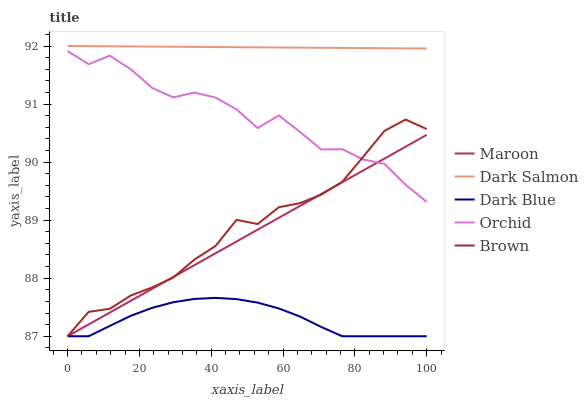Does Dark Blue have the minimum area under the curve?
Answer yes or no. Yes. Does Dark Salmon have the maximum area under the curve?
Answer yes or no. Yes. Does Dark Salmon have the minimum area under the curve?
Answer yes or no. No. Does Dark Blue have the maximum area under the curve?
Answer yes or no. No. Is Dark Salmon the smoothest?
Answer yes or no. Yes. Is Orchid the roughest?
Answer yes or no. Yes. Is Dark Blue the smoothest?
Answer yes or no. No. Is Dark Blue the roughest?
Answer yes or no. No. Does Brown have the lowest value?
Answer yes or no. Yes. Does Dark Salmon have the lowest value?
Answer yes or no. No. Does Dark Salmon have the highest value?
Answer yes or no. Yes. Does Dark Blue have the highest value?
Answer yes or no. No. Is Orchid less than Dark Salmon?
Answer yes or no. Yes. Is Dark Salmon greater than Dark Blue?
Answer yes or no. Yes. Does Maroon intersect Orchid?
Answer yes or no. Yes. Is Maroon less than Orchid?
Answer yes or no. No. Is Maroon greater than Orchid?
Answer yes or no. No. Does Orchid intersect Dark Salmon?
Answer yes or no. No. 